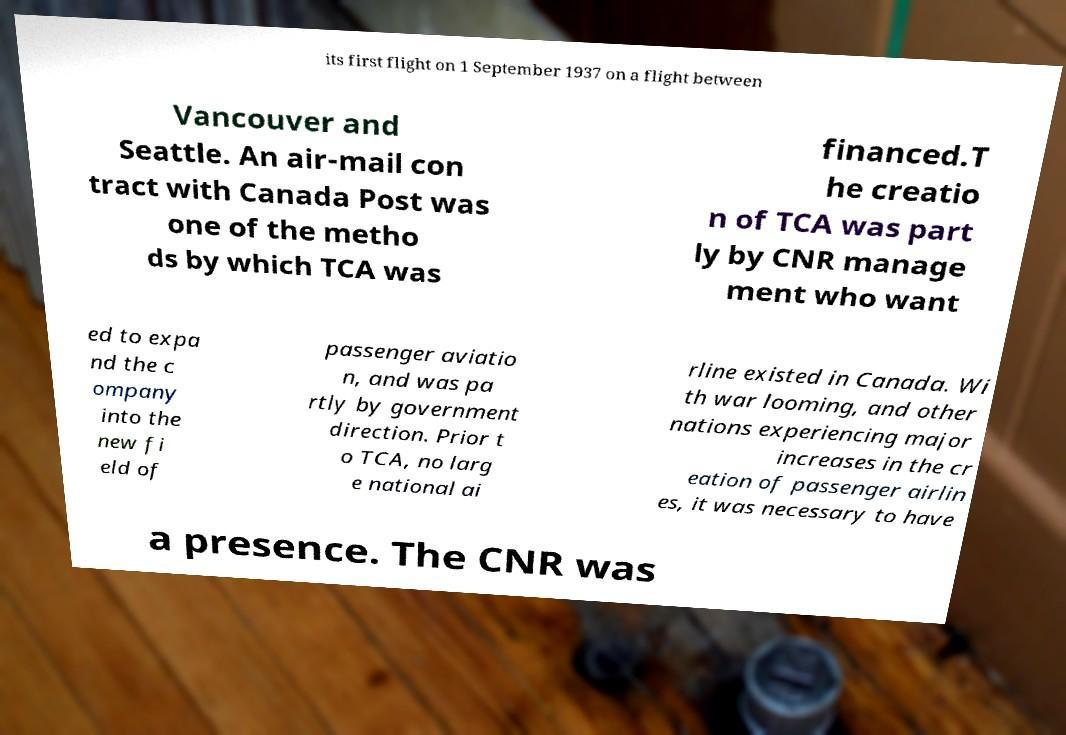Could you assist in decoding the text presented in this image and type it out clearly? its first flight on 1 September 1937 on a flight between Vancouver and Seattle. An air-mail con tract with Canada Post was one of the metho ds by which TCA was financed.T he creatio n of TCA was part ly by CNR manage ment who want ed to expa nd the c ompany into the new fi eld of passenger aviatio n, and was pa rtly by government direction. Prior t o TCA, no larg e national ai rline existed in Canada. Wi th war looming, and other nations experiencing major increases in the cr eation of passenger airlin es, it was necessary to have a presence. The CNR was 